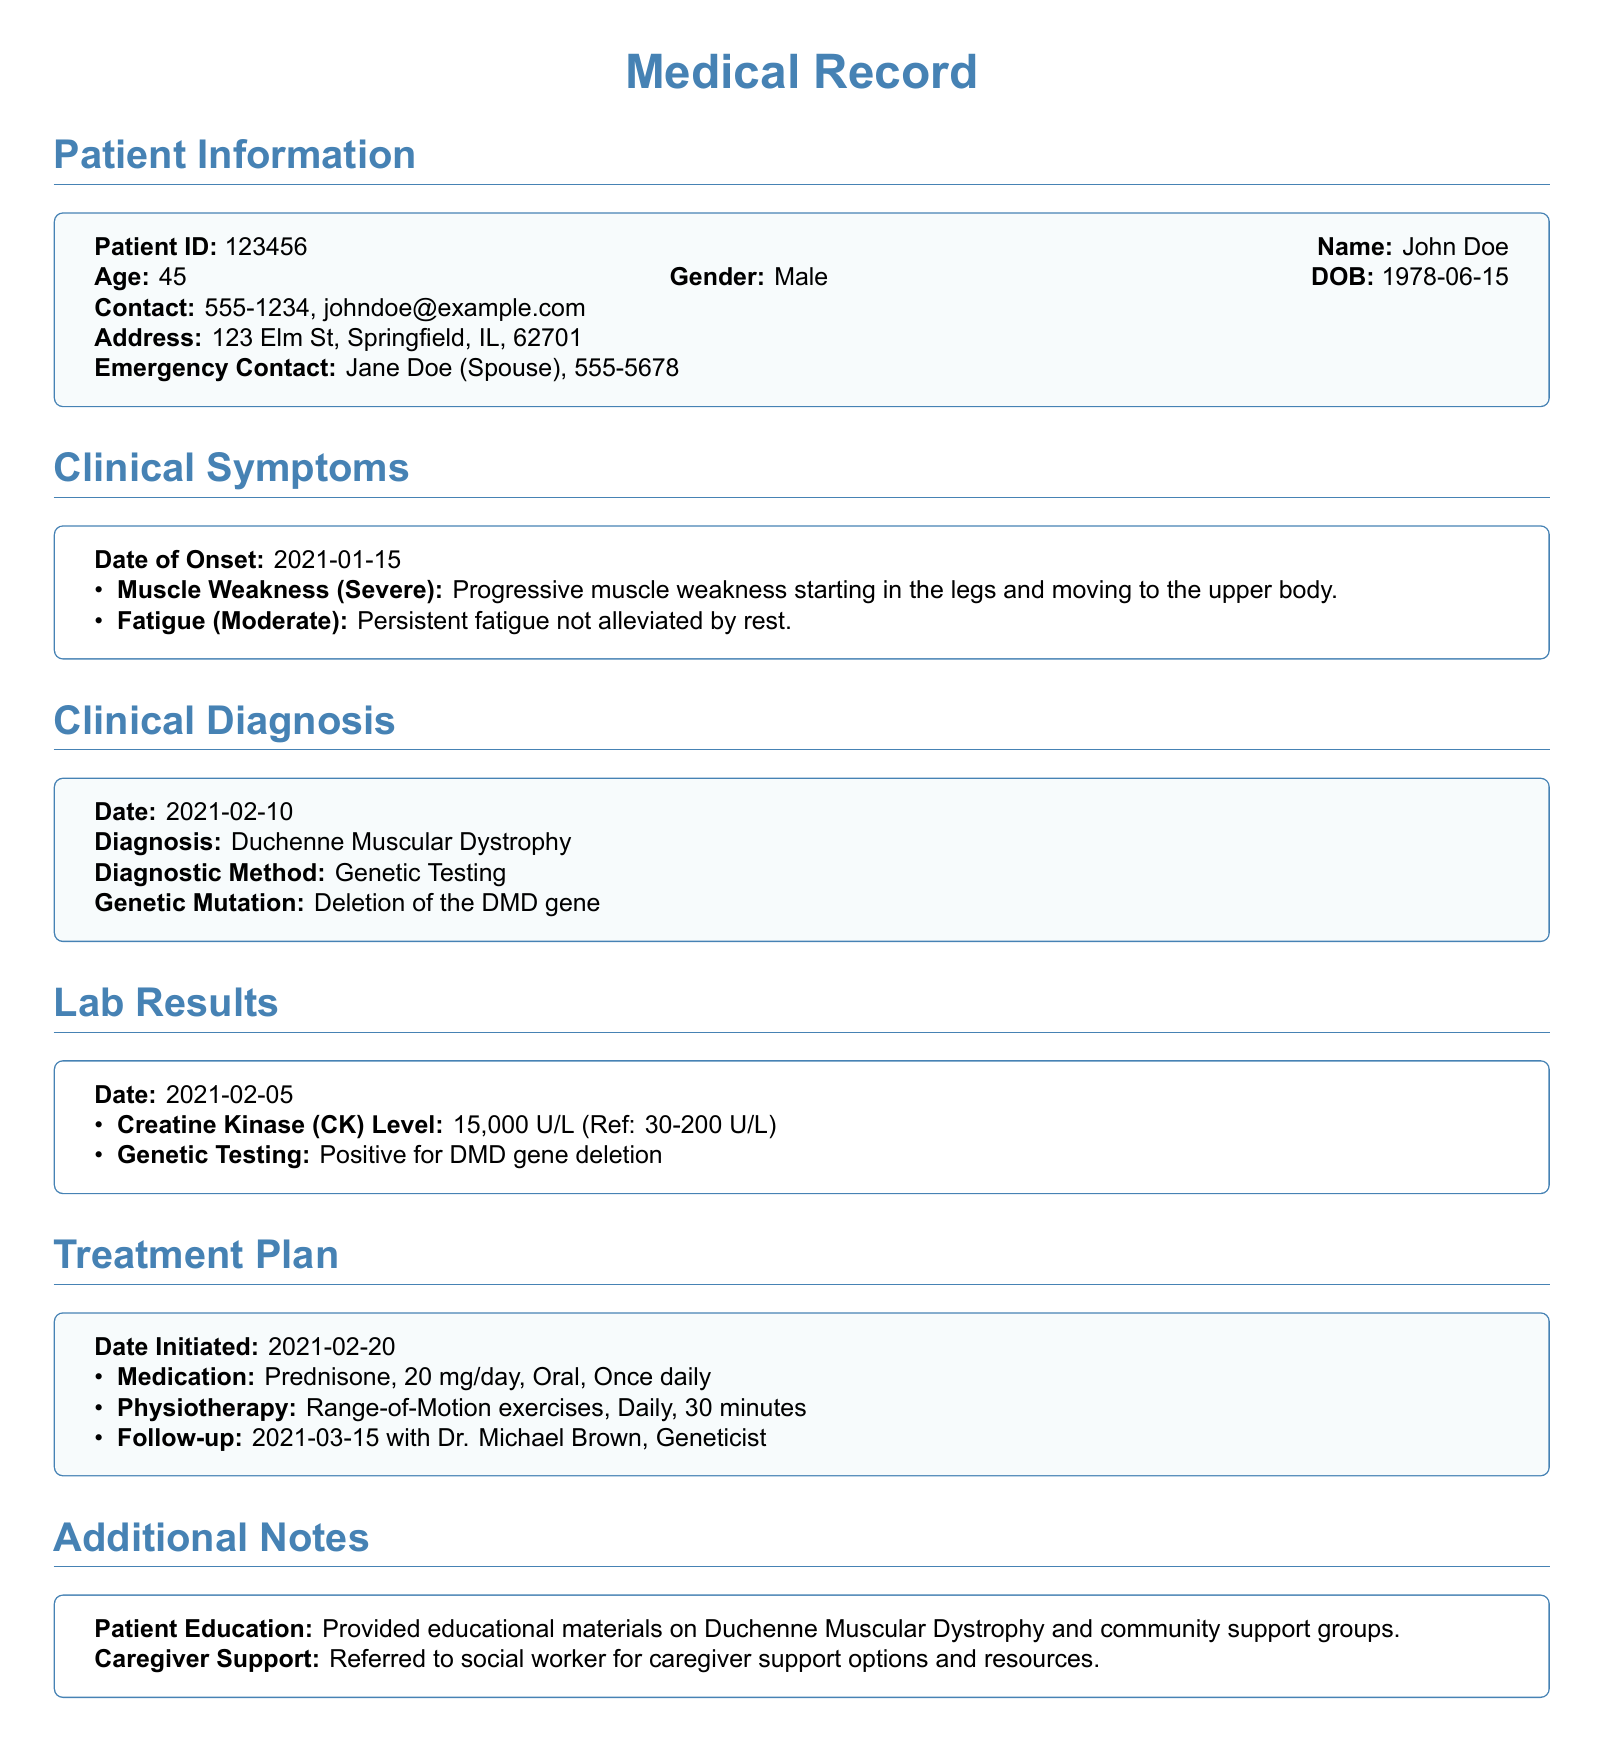What is the patient ID? The patient ID is found in the Patient Information section.
Answer: 123456 What is the diagnosis made on February 10, 2021? The diagnosis is stated in the Clinical Diagnosis section.
Answer: Duchenne Muscular Dystrophy What is the level of Creatine Kinase reported? The level is provided in the Lab Results section.
Answer: 15,000 U/L What medication is prescribed in the Treatment Plan? The medication is listed in the Treatment Plan section.
Answer: Prednisone What date was the genetic testing performed? The date of the genetic testing is mentioned in the Lab Results section.
Answer: 2021-02-05 What symptoms are associated with the patient’s condition? Symptoms are detailed in the Clinical Symptoms section.
Answer: Muscle Weakness, Fatigue How often is physiotherapy recommended? The frequency of physiotherapy is specified in the Treatment Plan section.
Answer: Daily What additional support was offered to the caregiver? Additional support options are noted in the Additional Notes section.
Answer: Caregiver support options and resources When is the follow-up appointment scheduled? The follow-up appointment date is found in the Treatment Plan section.
Answer: 2021-03-15 